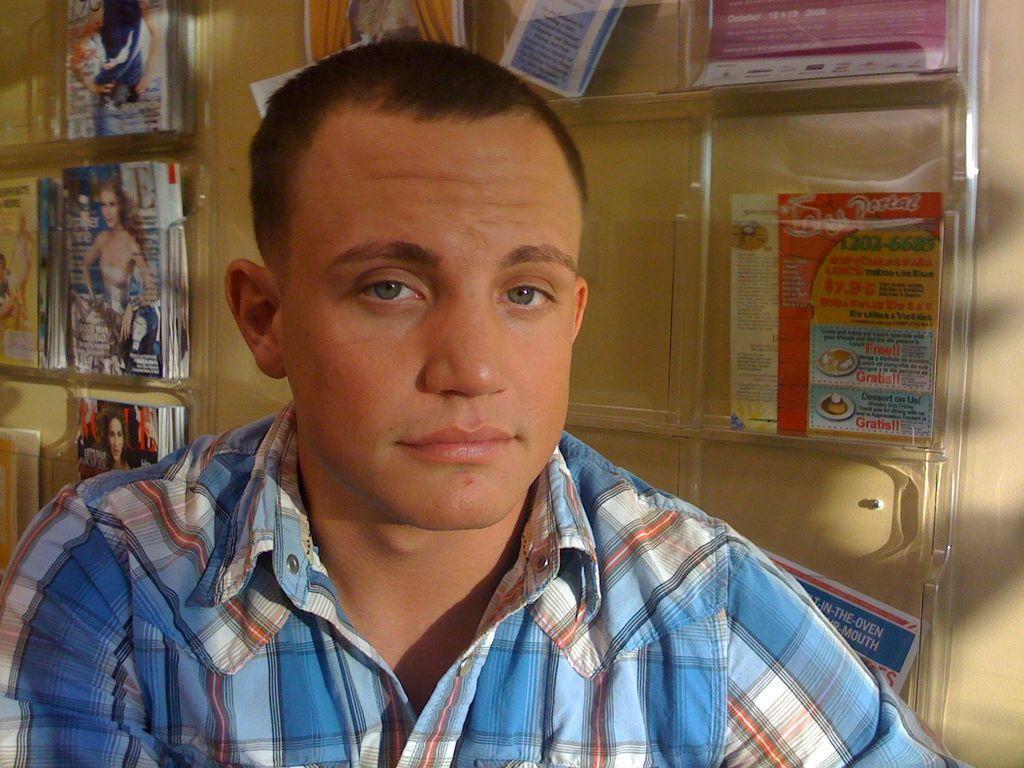In one or two sentences, can you explain what this image depicts? In this image, we can see a person wearing clothes. In the background, we can see flyers and magazines. 